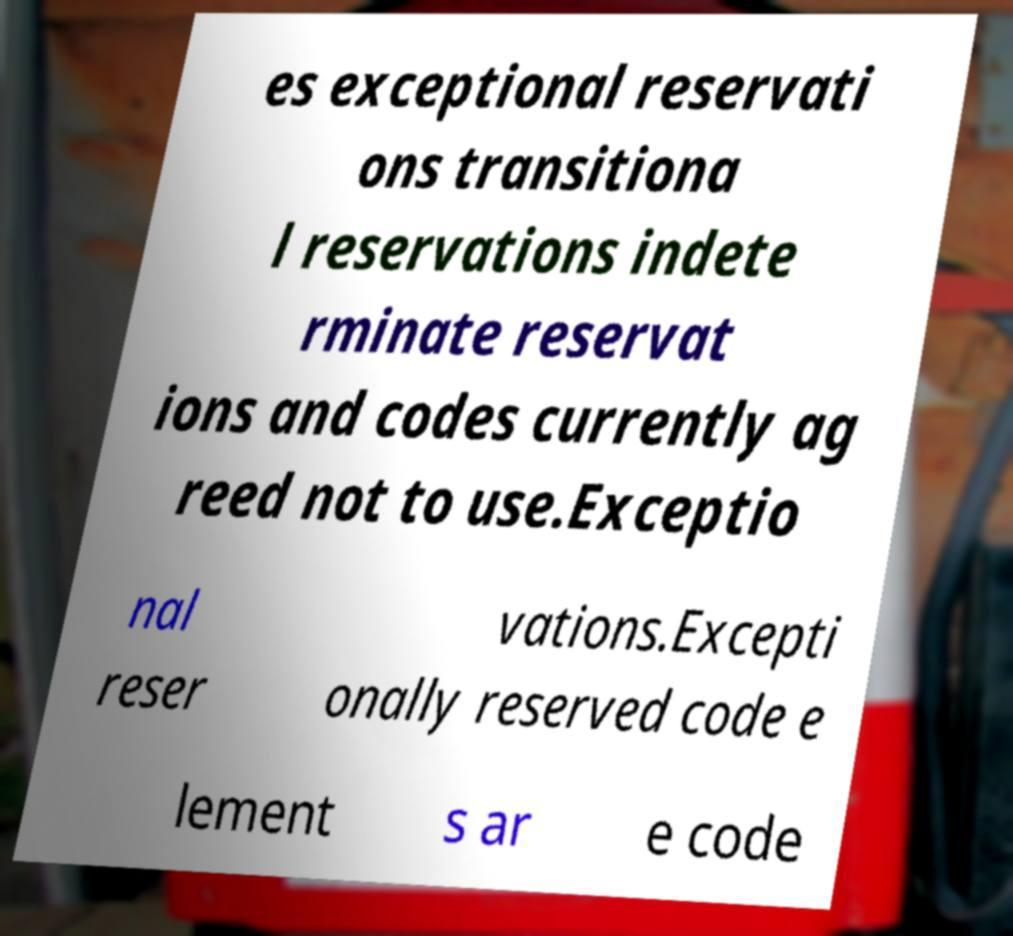What messages or text are displayed in this image? I need them in a readable, typed format. es exceptional reservati ons transitiona l reservations indete rminate reservat ions and codes currently ag reed not to use.Exceptio nal reser vations.Excepti onally reserved code e lement s ar e code 